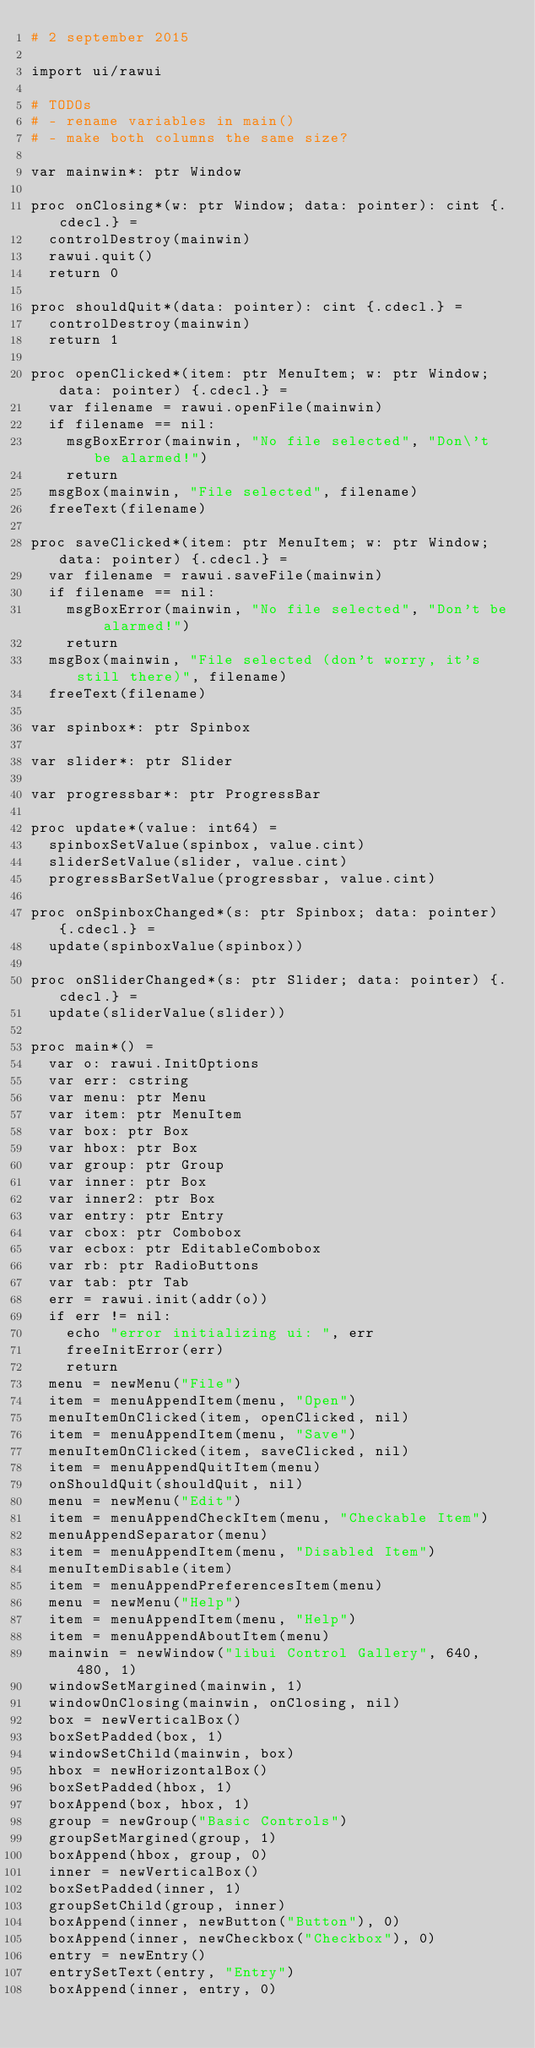<code> <loc_0><loc_0><loc_500><loc_500><_Nim_># 2 september 2015

import ui/rawui

# TODOs
# - rename variables in main()
# - make both columns the same size?

var mainwin*: ptr Window

proc onClosing*(w: ptr Window; data: pointer): cint {.cdecl.} =
  controlDestroy(mainwin)
  rawui.quit()
  return 0

proc shouldQuit*(data: pointer): cint {.cdecl.} =
  controlDestroy(mainwin)
  return 1

proc openClicked*(item: ptr MenuItem; w: ptr Window; data: pointer) {.cdecl.} =
  var filename = rawui.openFile(mainwin)
  if filename == nil:
    msgBoxError(mainwin, "No file selected", "Don\'t be alarmed!")
    return
  msgBox(mainwin, "File selected", filename)
  freeText(filename)

proc saveClicked*(item: ptr MenuItem; w: ptr Window; data: pointer) {.cdecl.} =
  var filename = rawui.saveFile(mainwin)
  if filename == nil:
    msgBoxError(mainwin, "No file selected", "Don't be alarmed!")
    return
  msgBox(mainwin, "File selected (don't worry, it's still there)", filename)
  freeText(filename)

var spinbox*: ptr Spinbox

var slider*: ptr Slider

var progressbar*: ptr ProgressBar

proc update*(value: int64) =
  spinboxSetValue(spinbox, value.cint)
  sliderSetValue(slider, value.cint)
  progressBarSetValue(progressbar, value.cint)

proc onSpinboxChanged*(s: ptr Spinbox; data: pointer) {.cdecl.} =
  update(spinboxValue(spinbox))

proc onSliderChanged*(s: ptr Slider; data: pointer) {.cdecl.} =
  update(sliderValue(slider))

proc main*() =
  var o: rawui.InitOptions
  var err: cstring
  var menu: ptr Menu
  var item: ptr MenuItem
  var box: ptr Box
  var hbox: ptr Box
  var group: ptr Group
  var inner: ptr Box
  var inner2: ptr Box
  var entry: ptr Entry
  var cbox: ptr Combobox
  var ecbox: ptr EditableCombobox
  var rb: ptr RadioButtons
  var tab: ptr Tab
  err = rawui.init(addr(o))
  if err != nil:
    echo "error initializing ui: ", err
    freeInitError(err)
    return
  menu = newMenu("File")
  item = menuAppendItem(menu, "Open")
  menuItemOnClicked(item, openClicked, nil)
  item = menuAppendItem(menu, "Save")
  menuItemOnClicked(item, saveClicked, nil)
  item = menuAppendQuitItem(menu)
  onShouldQuit(shouldQuit, nil)
  menu = newMenu("Edit")
  item = menuAppendCheckItem(menu, "Checkable Item")
  menuAppendSeparator(menu)
  item = menuAppendItem(menu, "Disabled Item")
  menuItemDisable(item)
  item = menuAppendPreferencesItem(menu)
  menu = newMenu("Help")
  item = menuAppendItem(menu, "Help")
  item = menuAppendAboutItem(menu)
  mainwin = newWindow("libui Control Gallery", 640, 480, 1)
  windowSetMargined(mainwin, 1)
  windowOnClosing(mainwin, onClosing, nil)
  box = newVerticalBox()
  boxSetPadded(box, 1)
  windowSetChild(mainwin, box)
  hbox = newHorizontalBox()
  boxSetPadded(hbox, 1)
  boxAppend(box, hbox, 1)
  group = newGroup("Basic Controls")
  groupSetMargined(group, 1)
  boxAppend(hbox, group, 0)
  inner = newVerticalBox()
  boxSetPadded(inner, 1)
  groupSetChild(group, inner)
  boxAppend(inner, newButton("Button"), 0)
  boxAppend(inner, newCheckbox("Checkbox"), 0)
  entry = newEntry()
  entrySetText(entry, "Entry")
  boxAppend(inner, entry, 0)</code> 